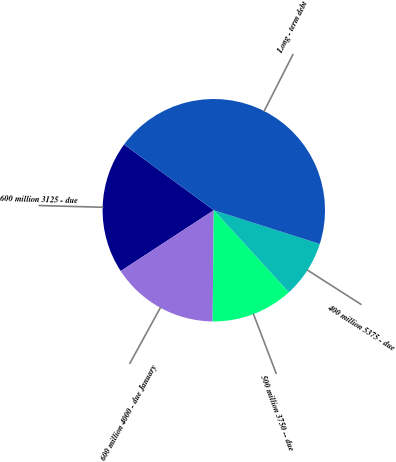Convert chart to OTSL. <chart><loc_0><loc_0><loc_500><loc_500><pie_chart><fcel>600 million 3125 - due<fcel>600 million 4000 - due January<fcel>500 million 3750 -- due<fcel>400 million 5375 - due<fcel>Long - term debt<nl><fcel>19.27%<fcel>15.62%<fcel>11.96%<fcel>8.31%<fcel>44.84%<nl></chart> 